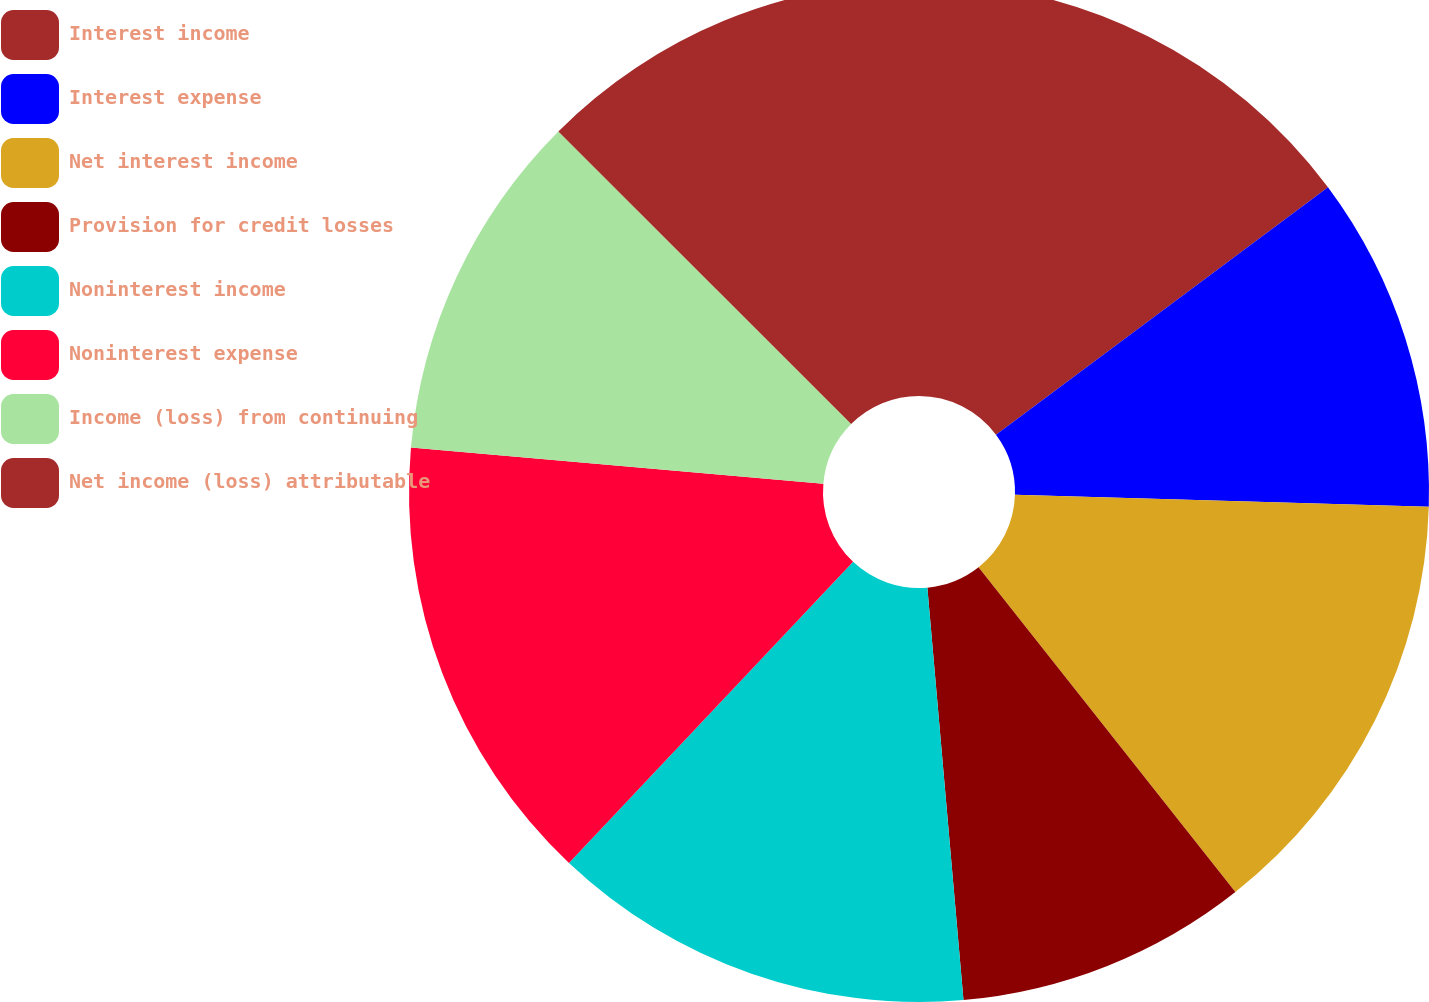<chart> <loc_0><loc_0><loc_500><loc_500><pie_chart><fcel>Interest income<fcel>Interest expense<fcel>Net interest income<fcel>Provision for credit losses<fcel>Noninterest income<fcel>Noninterest expense<fcel>Income (loss) from continuing<fcel>Net income (loss) attributable<nl><fcel>14.81%<fcel>10.65%<fcel>13.89%<fcel>9.26%<fcel>13.43%<fcel>14.35%<fcel>11.11%<fcel>12.5%<nl></chart> 